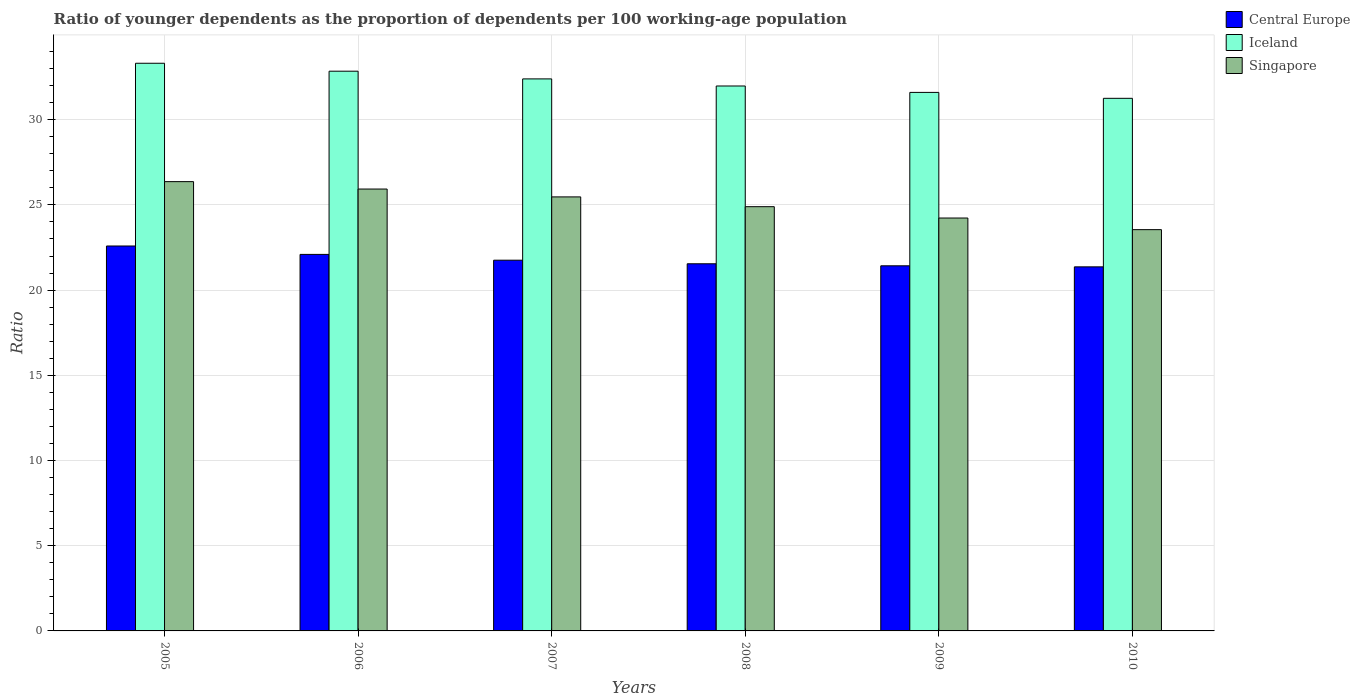Are the number of bars on each tick of the X-axis equal?
Keep it short and to the point. Yes. How many bars are there on the 6th tick from the left?
Ensure brevity in your answer.  3. What is the label of the 6th group of bars from the left?
Provide a short and direct response. 2010. In how many cases, is the number of bars for a given year not equal to the number of legend labels?
Ensure brevity in your answer.  0. What is the age dependency ratio(young) in Iceland in 2008?
Your answer should be very brief. 31.98. Across all years, what is the maximum age dependency ratio(young) in Iceland?
Make the answer very short. 33.31. Across all years, what is the minimum age dependency ratio(young) in Singapore?
Give a very brief answer. 23.55. In which year was the age dependency ratio(young) in Singapore maximum?
Your answer should be compact. 2005. In which year was the age dependency ratio(young) in Iceland minimum?
Your response must be concise. 2010. What is the total age dependency ratio(young) in Singapore in the graph?
Provide a succinct answer. 150.44. What is the difference between the age dependency ratio(young) in Singapore in 2008 and that in 2009?
Your answer should be compact. 0.67. What is the difference between the age dependency ratio(young) in Singapore in 2005 and the age dependency ratio(young) in Iceland in 2006?
Your answer should be compact. -6.48. What is the average age dependency ratio(young) in Central Europe per year?
Keep it short and to the point. 21.8. In the year 2010, what is the difference between the age dependency ratio(young) in Central Europe and age dependency ratio(young) in Singapore?
Offer a terse response. -2.18. What is the ratio of the age dependency ratio(young) in Central Europe in 2007 to that in 2009?
Offer a terse response. 1.02. What is the difference between the highest and the second highest age dependency ratio(young) in Iceland?
Provide a short and direct response. 0.47. What is the difference between the highest and the lowest age dependency ratio(young) in Iceland?
Offer a very short reply. 2.06. In how many years, is the age dependency ratio(young) in Iceland greater than the average age dependency ratio(young) in Iceland taken over all years?
Offer a terse response. 3. Is it the case that in every year, the sum of the age dependency ratio(young) in Iceland and age dependency ratio(young) in Singapore is greater than the age dependency ratio(young) in Central Europe?
Provide a short and direct response. Yes. Are all the bars in the graph horizontal?
Offer a terse response. No. How many years are there in the graph?
Offer a very short reply. 6. Does the graph contain any zero values?
Offer a terse response. No. What is the title of the graph?
Your response must be concise. Ratio of younger dependents as the proportion of dependents per 100 working-age population. What is the label or title of the X-axis?
Give a very brief answer. Years. What is the label or title of the Y-axis?
Give a very brief answer. Ratio. What is the Ratio of Central Europe in 2005?
Your response must be concise. 22.59. What is the Ratio of Iceland in 2005?
Your response must be concise. 33.31. What is the Ratio in Singapore in 2005?
Your answer should be compact. 26.37. What is the Ratio of Central Europe in 2006?
Give a very brief answer. 22.1. What is the Ratio in Iceland in 2006?
Provide a succinct answer. 32.85. What is the Ratio in Singapore in 2006?
Ensure brevity in your answer.  25.93. What is the Ratio in Central Europe in 2007?
Provide a short and direct response. 21.76. What is the Ratio of Iceland in 2007?
Provide a succinct answer. 32.39. What is the Ratio in Singapore in 2007?
Your answer should be compact. 25.47. What is the Ratio in Central Europe in 2008?
Give a very brief answer. 21.55. What is the Ratio in Iceland in 2008?
Keep it short and to the point. 31.98. What is the Ratio of Singapore in 2008?
Provide a succinct answer. 24.9. What is the Ratio of Central Europe in 2009?
Your response must be concise. 21.43. What is the Ratio in Iceland in 2009?
Your response must be concise. 31.6. What is the Ratio of Singapore in 2009?
Ensure brevity in your answer.  24.23. What is the Ratio of Central Europe in 2010?
Offer a very short reply. 21.36. What is the Ratio in Iceland in 2010?
Offer a very short reply. 31.25. What is the Ratio of Singapore in 2010?
Ensure brevity in your answer.  23.55. Across all years, what is the maximum Ratio in Central Europe?
Your answer should be compact. 22.59. Across all years, what is the maximum Ratio of Iceland?
Offer a terse response. 33.31. Across all years, what is the maximum Ratio of Singapore?
Provide a succinct answer. 26.37. Across all years, what is the minimum Ratio of Central Europe?
Keep it short and to the point. 21.36. Across all years, what is the minimum Ratio of Iceland?
Your answer should be compact. 31.25. Across all years, what is the minimum Ratio in Singapore?
Ensure brevity in your answer.  23.55. What is the total Ratio of Central Europe in the graph?
Provide a succinct answer. 130.78. What is the total Ratio of Iceland in the graph?
Your answer should be very brief. 193.39. What is the total Ratio of Singapore in the graph?
Keep it short and to the point. 150.44. What is the difference between the Ratio in Central Europe in 2005 and that in 2006?
Keep it short and to the point. 0.49. What is the difference between the Ratio in Iceland in 2005 and that in 2006?
Your answer should be compact. 0.47. What is the difference between the Ratio of Singapore in 2005 and that in 2006?
Your response must be concise. 0.44. What is the difference between the Ratio of Central Europe in 2005 and that in 2007?
Provide a short and direct response. 0.83. What is the difference between the Ratio of Iceland in 2005 and that in 2007?
Your answer should be very brief. 0.92. What is the difference between the Ratio of Singapore in 2005 and that in 2007?
Keep it short and to the point. 0.9. What is the difference between the Ratio in Central Europe in 2005 and that in 2008?
Ensure brevity in your answer.  1.04. What is the difference between the Ratio in Iceland in 2005 and that in 2008?
Your answer should be compact. 1.33. What is the difference between the Ratio in Singapore in 2005 and that in 2008?
Keep it short and to the point. 1.47. What is the difference between the Ratio of Central Europe in 2005 and that in 2009?
Ensure brevity in your answer.  1.16. What is the difference between the Ratio of Iceland in 2005 and that in 2009?
Your response must be concise. 1.71. What is the difference between the Ratio in Singapore in 2005 and that in 2009?
Make the answer very short. 2.14. What is the difference between the Ratio in Central Europe in 2005 and that in 2010?
Provide a short and direct response. 1.22. What is the difference between the Ratio in Iceland in 2005 and that in 2010?
Offer a very short reply. 2.06. What is the difference between the Ratio of Singapore in 2005 and that in 2010?
Your response must be concise. 2.82. What is the difference between the Ratio in Central Europe in 2006 and that in 2007?
Your response must be concise. 0.34. What is the difference between the Ratio in Iceland in 2006 and that in 2007?
Your answer should be compact. 0.45. What is the difference between the Ratio of Singapore in 2006 and that in 2007?
Offer a very short reply. 0.46. What is the difference between the Ratio of Central Europe in 2006 and that in 2008?
Make the answer very short. 0.55. What is the difference between the Ratio of Iceland in 2006 and that in 2008?
Provide a succinct answer. 0.87. What is the difference between the Ratio in Singapore in 2006 and that in 2008?
Offer a terse response. 1.03. What is the difference between the Ratio of Central Europe in 2006 and that in 2009?
Offer a terse response. 0.67. What is the difference between the Ratio in Iceland in 2006 and that in 2009?
Your answer should be compact. 1.24. What is the difference between the Ratio of Singapore in 2006 and that in 2009?
Give a very brief answer. 1.7. What is the difference between the Ratio of Central Europe in 2006 and that in 2010?
Offer a terse response. 0.73. What is the difference between the Ratio of Iceland in 2006 and that in 2010?
Keep it short and to the point. 1.59. What is the difference between the Ratio of Singapore in 2006 and that in 2010?
Make the answer very short. 2.38. What is the difference between the Ratio of Central Europe in 2007 and that in 2008?
Provide a short and direct response. 0.21. What is the difference between the Ratio in Iceland in 2007 and that in 2008?
Provide a succinct answer. 0.42. What is the difference between the Ratio of Singapore in 2007 and that in 2008?
Provide a short and direct response. 0.57. What is the difference between the Ratio in Central Europe in 2007 and that in 2009?
Make the answer very short. 0.33. What is the difference between the Ratio of Iceland in 2007 and that in 2009?
Give a very brief answer. 0.79. What is the difference between the Ratio of Singapore in 2007 and that in 2009?
Keep it short and to the point. 1.24. What is the difference between the Ratio of Central Europe in 2007 and that in 2010?
Give a very brief answer. 0.39. What is the difference between the Ratio of Iceland in 2007 and that in 2010?
Give a very brief answer. 1.14. What is the difference between the Ratio of Singapore in 2007 and that in 2010?
Provide a succinct answer. 1.92. What is the difference between the Ratio in Central Europe in 2008 and that in 2009?
Your answer should be very brief. 0.12. What is the difference between the Ratio in Iceland in 2008 and that in 2009?
Offer a very short reply. 0.38. What is the difference between the Ratio in Singapore in 2008 and that in 2009?
Your answer should be very brief. 0.67. What is the difference between the Ratio in Central Europe in 2008 and that in 2010?
Give a very brief answer. 0.18. What is the difference between the Ratio in Iceland in 2008 and that in 2010?
Provide a short and direct response. 0.72. What is the difference between the Ratio in Singapore in 2008 and that in 2010?
Ensure brevity in your answer.  1.35. What is the difference between the Ratio in Central Europe in 2009 and that in 2010?
Make the answer very short. 0.06. What is the difference between the Ratio of Iceland in 2009 and that in 2010?
Keep it short and to the point. 0.35. What is the difference between the Ratio in Singapore in 2009 and that in 2010?
Make the answer very short. 0.68. What is the difference between the Ratio of Central Europe in 2005 and the Ratio of Iceland in 2006?
Offer a terse response. -10.26. What is the difference between the Ratio in Central Europe in 2005 and the Ratio in Singapore in 2006?
Ensure brevity in your answer.  -3.34. What is the difference between the Ratio in Iceland in 2005 and the Ratio in Singapore in 2006?
Provide a succinct answer. 7.38. What is the difference between the Ratio of Central Europe in 2005 and the Ratio of Iceland in 2007?
Provide a succinct answer. -9.81. What is the difference between the Ratio in Central Europe in 2005 and the Ratio in Singapore in 2007?
Your response must be concise. -2.88. What is the difference between the Ratio of Iceland in 2005 and the Ratio of Singapore in 2007?
Your response must be concise. 7.84. What is the difference between the Ratio in Central Europe in 2005 and the Ratio in Iceland in 2008?
Give a very brief answer. -9.39. What is the difference between the Ratio in Central Europe in 2005 and the Ratio in Singapore in 2008?
Provide a short and direct response. -2.31. What is the difference between the Ratio of Iceland in 2005 and the Ratio of Singapore in 2008?
Provide a succinct answer. 8.42. What is the difference between the Ratio of Central Europe in 2005 and the Ratio of Iceland in 2009?
Provide a succinct answer. -9.01. What is the difference between the Ratio of Central Europe in 2005 and the Ratio of Singapore in 2009?
Offer a terse response. -1.64. What is the difference between the Ratio of Iceland in 2005 and the Ratio of Singapore in 2009?
Your response must be concise. 9.08. What is the difference between the Ratio of Central Europe in 2005 and the Ratio of Iceland in 2010?
Offer a very short reply. -8.67. What is the difference between the Ratio in Central Europe in 2005 and the Ratio in Singapore in 2010?
Your answer should be compact. -0.96. What is the difference between the Ratio of Iceland in 2005 and the Ratio of Singapore in 2010?
Provide a succinct answer. 9.76. What is the difference between the Ratio of Central Europe in 2006 and the Ratio of Iceland in 2007?
Your answer should be compact. -10.3. What is the difference between the Ratio in Central Europe in 2006 and the Ratio in Singapore in 2007?
Ensure brevity in your answer.  -3.37. What is the difference between the Ratio in Iceland in 2006 and the Ratio in Singapore in 2007?
Offer a very short reply. 7.38. What is the difference between the Ratio in Central Europe in 2006 and the Ratio in Iceland in 2008?
Provide a short and direct response. -9.88. What is the difference between the Ratio in Iceland in 2006 and the Ratio in Singapore in 2008?
Give a very brief answer. 7.95. What is the difference between the Ratio of Central Europe in 2006 and the Ratio of Iceland in 2009?
Make the answer very short. -9.51. What is the difference between the Ratio in Central Europe in 2006 and the Ratio in Singapore in 2009?
Offer a very short reply. -2.13. What is the difference between the Ratio in Iceland in 2006 and the Ratio in Singapore in 2009?
Your answer should be compact. 8.62. What is the difference between the Ratio of Central Europe in 2006 and the Ratio of Iceland in 2010?
Provide a succinct answer. -9.16. What is the difference between the Ratio in Central Europe in 2006 and the Ratio in Singapore in 2010?
Offer a very short reply. -1.45. What is the difference between the Ratio in Iceland in 2006 and the Ratio in Singapore in 2010?
Give a very brief answer. 9.3. What is the difference between the Ratio of Central Europe in 2007 and the Ratio of Iceland in 2008?
Provide a succinct answer. -10.22. What is the difference between the Ratio of Central Europe in 2007 and the Ratio of Singapore in 2008?
Your response must be concise. -3.14. What is the difference between the Ratio in Iceland in 2007 and the Ratio in Singapore in 2008?
Give a very brief answer. 7.5. What is the difference between the Ratio in Central Europe in 2007 and the Ratio in Iceland in 2009?
Your response must be concise. -9.85. What is the difference between the Ratio of Central Europe in 2007 and the Ratio of Singapore in 2009?
Keep it short and to the point. -2.47. What is the difference between the Ratio in Iceland in 2007 and the Ratio in Singapore in 2009?
Ensure brevity in your answer.  8.16. What is the difference between the Ratio in Central Europe in 2007 and the Ratio in Iceland in 2010?
Ensure brevity in your answer.  -9.5. What is the difference between the Ratio of Central Europe in 2007 and the Ratio of Singapore in 2010?
Your answer should be compact. -1.79. What is the difference between the Ratio of Iceland in 2007 and the Ratio of Singapore in 2010?
Offer a very short reply. 8.85. What is the difference between the Ratio in Central Europe in 2008 and the Ratio in Iceland in 2009?
Offer a very short reply. -10.06. What is the difference between the Ratio of Central Europe in 2008 and the Ratio of Singapore in 2009?
Keep it short and to the point. -2.68. What is the difference between the Ratio of Iceland in 2008 and the Ratio of Singapore in 2009?
Offer a very short reply. 7.75. What is the difference between the Ratio in Central Europe in 2008 and the Ratio in Iceland in 2010?
Make the answer very short. -9.71. What is the difference between the Ratio of Central Europe in 2008 and the Ratio of Singapore in 2010?
Provide a short and direct response. -2. What is the difference between the Ratio in Iceland in 2008 and the Ratio in Singapore in 2010?
Make the answer very short. 8.43. What is the difference between the Ratio in Central Europe in 2009 and the Ratio in Iceland in 2010?
Your response must be concise. -9.83. What is the difference between the Ratio of Central Europe in 2009 and the Ratio of Singapore in 2010?
Your answer should be compact. -2.12. What is the difference between the Ratio of Iceland in 2009 and the Ratio of Singapore in 2010?
Provide a succinct answer. 8.05. What is the average Ratio in Central Europe per year?
Keep it short and to the point. 21.8. What is the average Ratio in Iceland per year?
Give a very brief answer. 32.23. What is the average Ratio of Singapore per year?
Make the answer very short. 25.07. In the year 2005, what is the difference between the Ratio in Central Europe and Ratio in Iceland?
Provide a succinct answer. -10.72. In the year 2005, what is the difference between the Ratio of Central Europe and Ratio of Singapore?
Offer a very short reply. -3.78. In the year 2005, what is the difference between the Ratio in Iceland and Ratio in Singapore?
Give a very brief answer. 6.95. In the year 2006, what is the difference between the Ratio of Central Europe and Ratio of Iceland?
Offer a very short reply. -10.75. In the year 2006, what is the difference between the Ratio in Central Europe and Ratio in Singapore?
Provide a succinct answer. -3.83. In the year 2006, what is the difference between the Ratio in Iceland and Ratio in Singapore?
Ensure brevity in your answer.  6.92. In the year 2007, what is the difference between the Ratio of Central Europe and Ratio of Iceland?
Offer a terse response. -10.64. In the year 2007, what is the difference between the Ratio in Central Europe and Ratio in Singapore?
Your response must be concise. -3.71. In the year 2007, what is the difference between the Ratio in Iceland and Ratio in Singapore?
Your response must be concise. 6.92. In the year 2008, what is the difference between the Ratio of Central Europe and Ratio of Iceland?
Offer a very short reply. -10.43. In the year 2008, what is the difference between the Ratio of Central Europe and Ratio of Singapore?
Offer a very short reply. -3.35. In the year 2008, what is the difference between the Ratio of Iceland and Ratio of Singapore?
Your response must be concise. 7.08. In the year 2009, what is the difference between the Ratio of Central Europe and Ratio of Iceland?
Provide a succinct answer. -10.18. In the year 2009, what is the difference between the Ratio of Central Europe and Ratio of Singapore?
Your answer should be very brief. -2.8. In the year 2009, what is the difference between the Ratio in Iceland and Ratio in Singapore?
Make the answer very short. 7.37. In the year 2010, what is the difference between the Ratio of Central Europe and Ratio of Iceland?
Ensure brevity in your answer.  -9.89. In the year 2010, what is the difference between the Ratio of Central Europe and Ratio of Singapore?
Offer a terse response. -2.18. In the year 2010, what is the difference between the Ratio of Iceland and Ratio of Singapore?
Offer a very short reply. 7.71. What is the ratio of the Ratio in Central Europe in 2005 to that in 2006?
Offer a terse response. 1.02. What is the ratio of the Ratio in Iceland in 2005 to that in 2006?
Your answer should be very brief. 1.01. What is the ratio of the Ratio of Singapore in 2005 to that in 2006?
Offer a terse response. 1.02. What is the ratio of the Ratio in Central Europe in 2005 to that in 2007?
Make the answer very short. 1.04. What is the ratio of the Ratio of Iceland in 2005 to that in 2007?
Your response must be concise. 1.03. What is the ratio of the Ratio in Singapore in 2005 to that in 2007?
Make the answer very short. 1.04. What is the ratio of the Ratio of Central Europe in 2005 to that in 2008?
Provide a short and direct response. 1.05. What is the ratio of the Ratio of Iceland in 2005 to that in 2008?
Give a very brief answer. 1.04. What is the ratio of the Ratio of Singapore in 2005 to that in 2008?
Your answer should be compact. 1.06. What is the ratio of the Ratio in Central Europe in 2005 to that in 2009?
Make the answer very short. 1.05. What is the ratio of the Ratio in Iceland in 2005 to that in 2009?
Offer a very short reply. 1.05. What is the ratio of the Ratio of Singapore in 2005 to that in 2009?
Provide a short and direct response. 1.09. What is the ratio of the Ratio of Central Europe in 2005 to that in 2010?
Provide a short and direct response. 1.06. What is the ratio of the Ratio of Iceland in 2005 to that in 2010?
Offer a very short reply. 1.07. What is the ratio of the Ratio in Singapore in 2005 to that in 2010?
Provide a succinct answer. 1.12. What is the ratio of the Ratio in Central Europe in 2006 to that in 2007?
Ensure brevity in your answer.  1.02. What is the ratio of the Ratio in Iceland in 2006 to that in 2007?
Ensure brevity in your answer.  1.01. What is the ratio of the Ratio in Singapore in 2006 to that in 2007?
Provide a succinct answer. 1.02. What is the ratio of the Ratio in Central Europe in 2006 to that in 2008?
Make the answer very short. 1.03. What is the ratio of the Ratio in Iceland in 2006 to that in 2008?
Provide a succinct answer. 1.03. What is the ratio of the Ratio in Singapore in 2006 to that in 2008?
Offer a terse response. 1.04. What is the ratio of the Ratio in Central Europe in 2006 to that in 2009?
Provide a short and direct response. 1.03. What is the ratio of the Ratio in Iceland in 2006 to that in 2009?
Make the answer very short. 1.04. What is the ratio of the Ratio of Singapore in 2006 to that in 2009?
Your response must be concise. 1.07. What is the ratio of the Ratio of Central Europe in 2006 to that in 2010?
Make the answer very short. 1.03. What is the ratio of the Ratio of Iceland in 2006 to that in 2010?
Give a very brief answer. 1.05. What is the ratio of the Ratio in Singapore in 2006 to that in 2010?
Your answer should be very brief. 1.1. What is the ratio of the Ratio of Central Europe in 2007 to that in 2008?
Provide a short and direct response. 1.01. What is the ratio of the Ratio in Iceland in 2007 to that in 2008?
Provide a short and direct response. 1.01. What is the ratio of the Ratio of Singapore in 2007 to that in 2008?
Provide a short and direct response. 1.02. What is the ratio of the Ratio in Central Europe in 2007 to that in 2009?
Ensure brevity in your answer.  1.02. What is the ratio of the Ratio of Iceland in 2007 to that in 2009?
Make the answer very short. 1.03. What is the ratio of the Ratio in Singapore in 2007 to that in 2009?
Offer a terse response. 1.05. What is the ratio of the Ratio of Central Europe in 2007 to that in 2010?
Offer a very short reply. 1.02. What is the ratio of the Ratio of Iceland in 2007 to that in 2010?
Provide a succinct answer. 1.04. What is the ratio of the Ratio of Singapore in 2007 to that in 2010?
Your answer should be very brief. 1.08. What is the ratio of the Ratio in Iceland in 2008 to that in 2009?
Your answer should be compact. 1.01. What is the ratio of the Ratio in Singapore in 2008 to that in 2009?
Ensure brevity in your answer.  1.03. What is the ratio of the Ratio of Central Europe in 2008 to that in 2010?
Make the answer very short. 1.01. What is the ratio of the Ratio in Iceland in 2008 to that in 2010?
Offer a very short reply. 1.02. What is the ratio of the Ratio in Singapore in 2008 to that in 2010?
Offer a very short reply. 1.06. What is the ratio of the Ratio of Iceland in 2009 to that in 2010?
Your response must be concise. 1.01. What is the difference between the highest and the second highest Ratio in Central Europe?
Your answer should be very brief. 0.49. What is the difference between the highest and the second highest Ratio in Iceland?
Keep it short and to the point. 0.47. What is the difference between the highest and the second highest Ratio of Singapore?
Ensure brevity in your answer.  0.44. What is the difference between the highest and the lowest Ratio of Central Europe?
Offer a terse response. 1.22. What is the difference between the highest and the lowest Ratio of Iceland?
Your answer should be very brief. 2.06. What is the difference between the highest and the lowest Ratio of Singapore?
Provide a short and direct response. 2.82. 